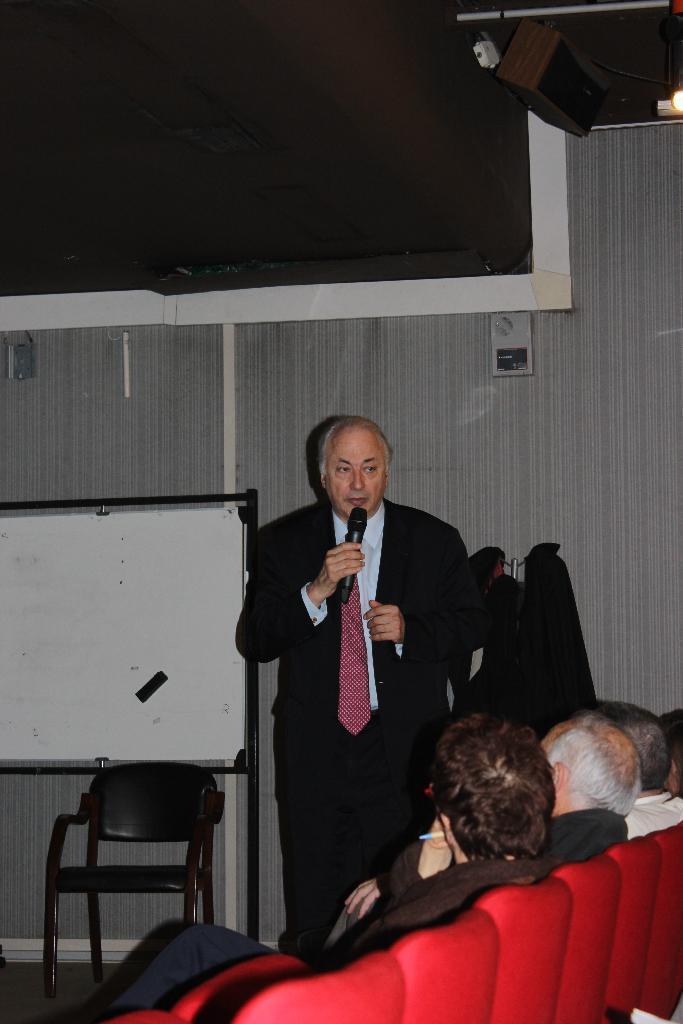In one or two sentences, can you explain what this image depicts? In the image there is a man holding a microphone and opened his mouth for talking. On right side there are group of people sitting on chair, on left we can see a white color board and a chair on top we can see speakers. 